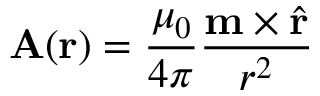Convert formula to latex. <formula><loc_0><loc_0><loc_500><loc_500>A ( r ) = { \frac { \mu _ { 0 } } { 4 \pi } } { \frac { m \times { \hat { r } } } { r ^ { 2 } } }</formula> 